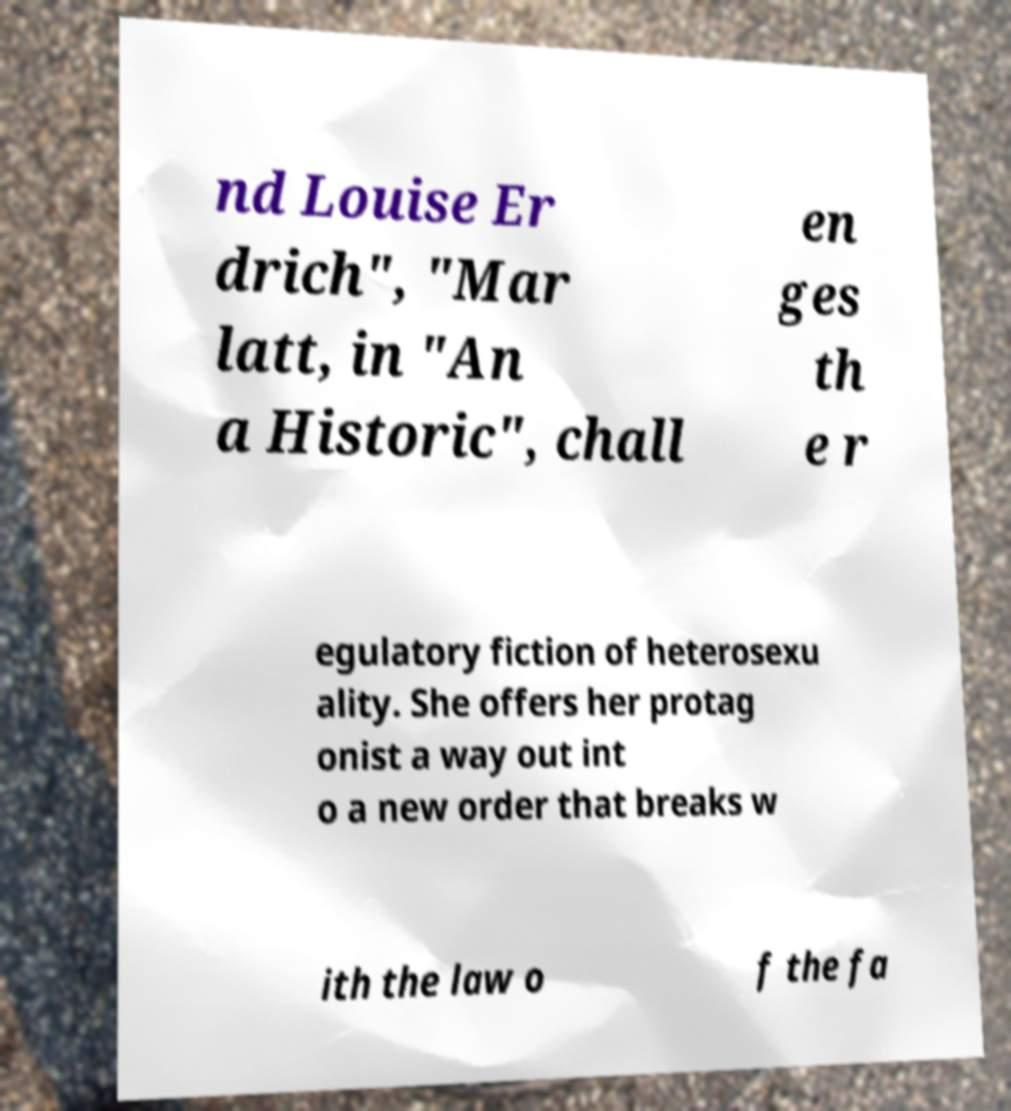I need the written content from this picture converted into text. Can you do that? nd Louise Er drich", "Mar latt, in "An a Historic", chall en ges th e r egulatory fiction of heterosexu ality. She offers her protag onist a way out int o a new order that breaks w ith the law o f the fa 